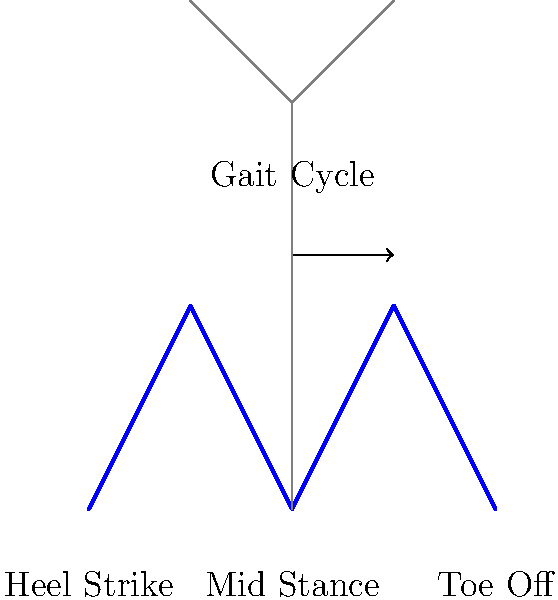As a documentary reviewer focusing on scientific content, you're analyzing a film about human biomechanics. The documentary presents a diagram similar to the one shown above, illustrating the leg movements during a gait cycle. What phase of the gait cycle is represented by the highest point in the curve, and what biomechanical action is occurring at this point? To answer this question, let's break down the gait cycle and analyze the diagram:

1. The gait cycle is divided into several phases, with the main ones being heel strike, mid stance, and toe off.

2. The diagram shows a curve representing the movement of the leg during walking, with the horizontal axis representing forward movement and the vertical axis representing vertical displacement.

3. The highest points in the curve occur at two locations, approximately at the 1/4 and 3/4 marks of the cycle.

4. These high points represent the mid stance phase of the gait cycle.

5. During mid stance, the following biomechanical actions occur:
   a. The body's center of mass is at its highest point.
   b. The supporting leg is directly under the body, bearing the full weight.
   c. The knee is slightly flexed to absorb shock.
   d. The opposite leg is in the swing phase, passing the supporting leg.

6. The most significant biomechanical action at this point is weight acceptance and single-leg support.

7. This phase is crucial for maintaining balance and preparing for the propulsive phase (toe off) that follows.

Therefore, the highest point in the curve represents the mid stance phase, and the primary biomechanical action occurring is weight acceptance and single-leg support.
Answer: Mid stance; weight acceptance and single-leg support 